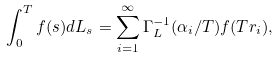<formula> <loc_0><loc_0><loc_500><loc_500>\int _ { 0 } ^ { T } f ( s ) d L _ { s } = \sum _ { i = 1 } ^ { \infty } \Gamma _ { L } ^ { - 1 } ( \alpha _ { i } / T ) f ( T r _ { i } ) ,</formula> 